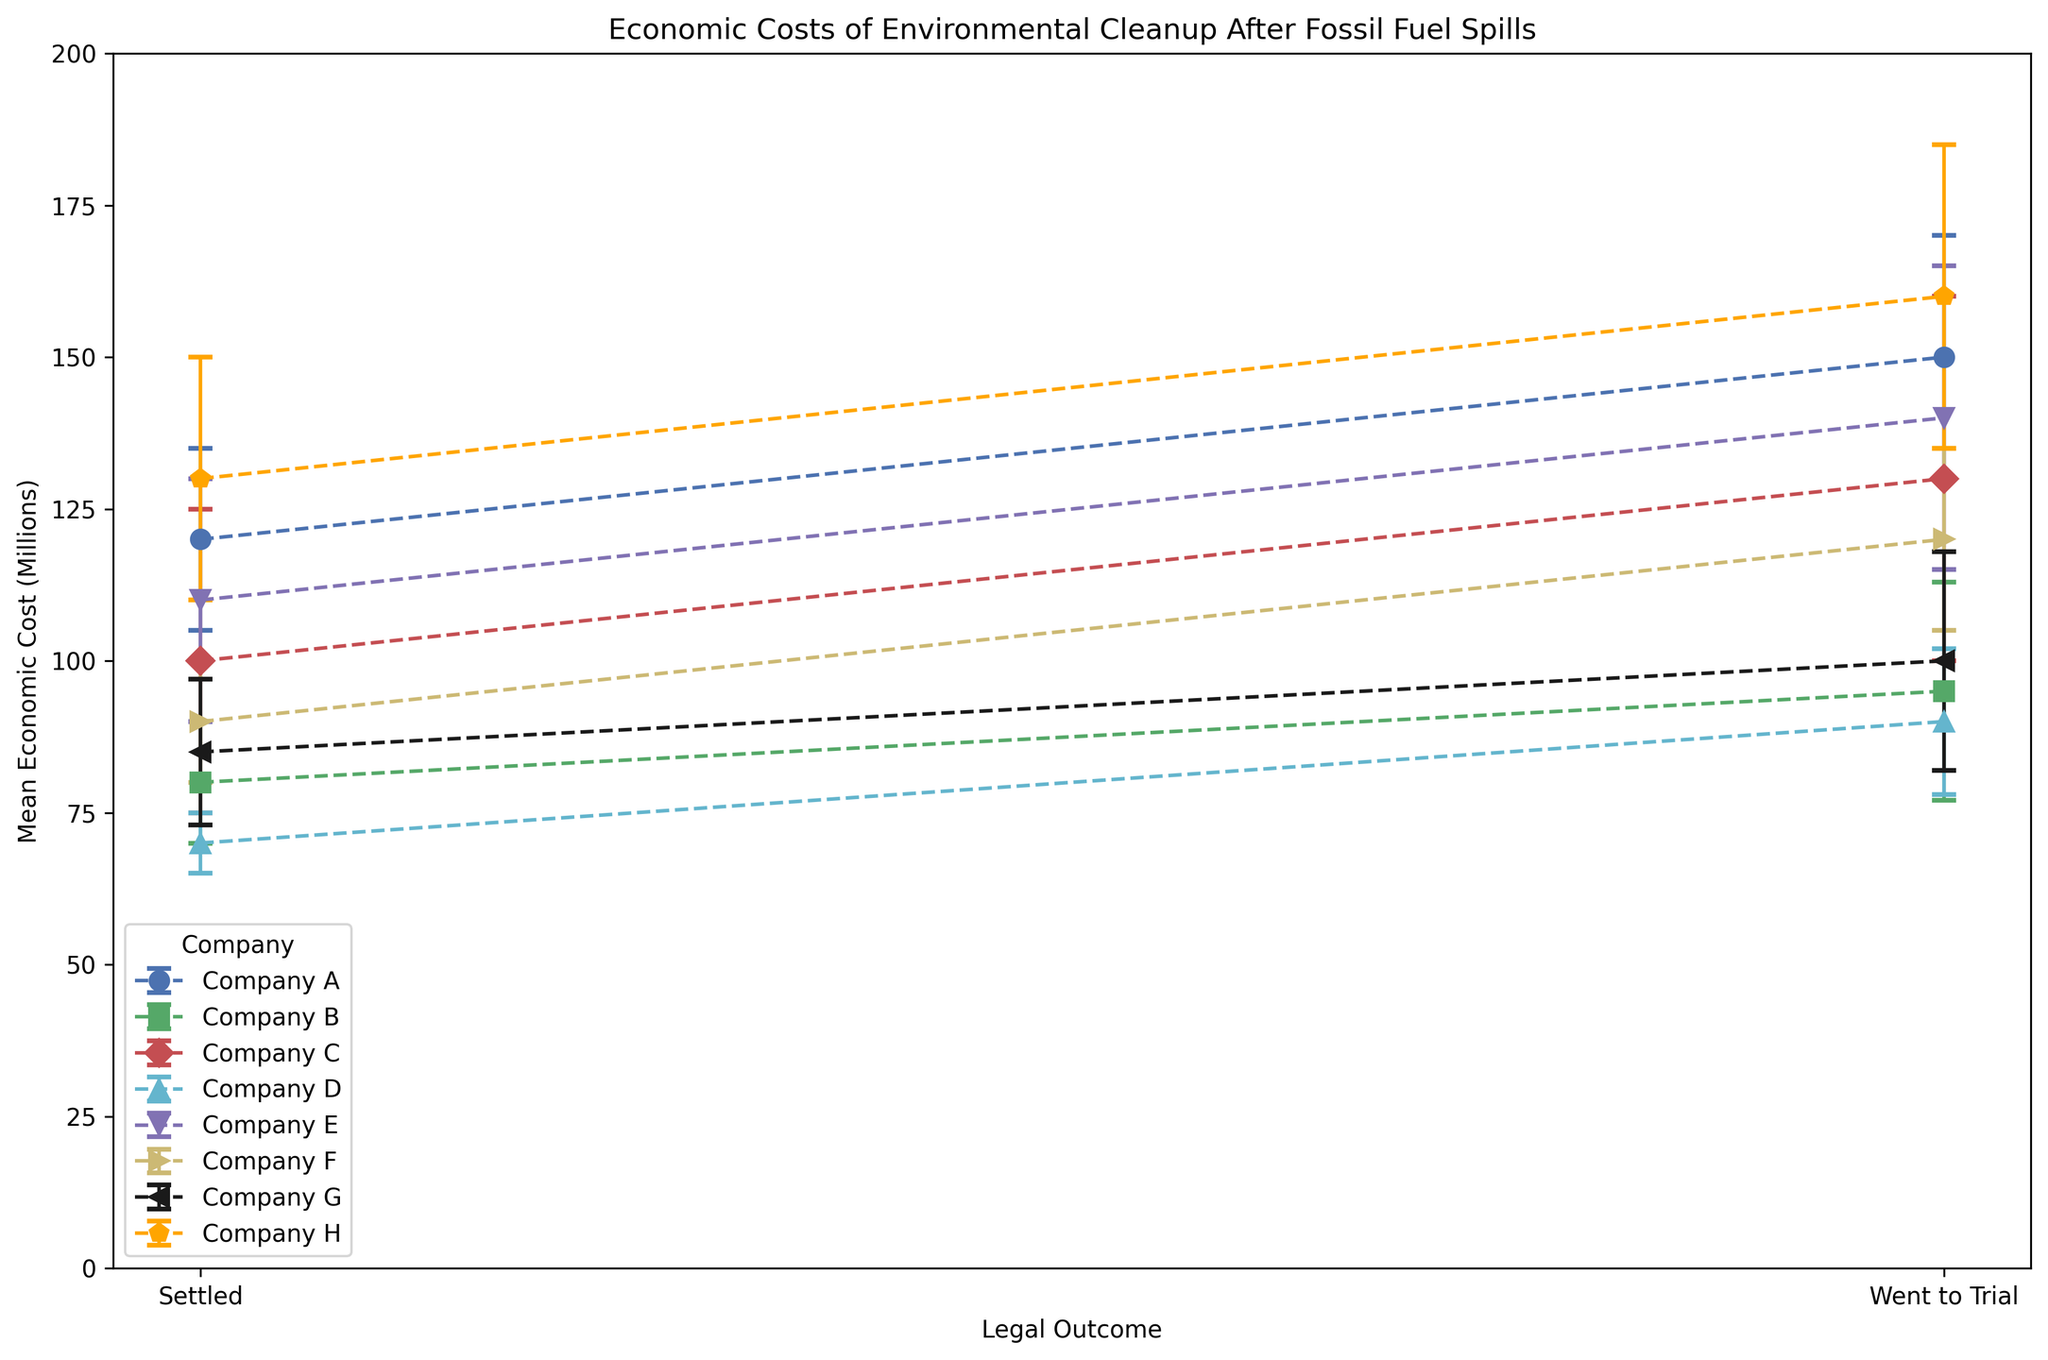What's the highest mean economic cost observed among all companies? To find the highest mean economic cost, look for the tallest error bar. The highest mean cost is for 'Company H' with 'Went to Trial' having a mean of 160 million.
Answer: 160 million Which company shows the smallest difference in mean economic cost between 'Settled' and 'Went to Trial' outcomes? To answer this, calculate the difference for each company. For 'Company D', the mean economic cost is 70 million for 'Settled' and 90 million for 'Went to Trial', a difference of 20 million, which is the smallest.
Answer: Company D How does 'Company C's' mean economic cost for 'Settled' compare to 'Company G's'? Look at the heights of the error bars for 'Settled' in both companies. 'Company C' has a mean cost of 100 million, and 'Company G' has a mean cost of 85 million. 'Company C' has a higher cost.
Answer: Company C is higher For 'Company E', what is the confidence interval (mean ± standard deviation) for 'Went to Trial'? For 'Company E' with 'Went to Trial', the mean is 140 million, and the standard deviation is 25 million. The confidence interval is (140 ± 25) million.
Answer: 115 to 165 million Compare the mean economic costs when settled between 'Company B' and 'Company H'. Which has a higher mean cost? By comparing the error bars for 'Settled', 'Company B' has a mean cost of 80 million, while 'Company H' has a mean cost of 130 million. 'Company H' has a higher mean cost.
Answer: Company H What is the range of mean economic costs for 'Settled' outcomes across all companies? The lowest mean economic cost for 'Settled' is 70 million ('Company D'), and the highest is 130 million ('Company H'). The range is (130 - 70) million.
Answer: 60 million Which legal outcome generally leads to higher economic costs based on the figure? Most companies show higher mean costs for 'Went to Trial' compared to 'Settled', indicated by taller bars for 'Went to Trial'.
Answer: Went to Trial Does 'Company A' exhibit a large variation in economic costs between 'Settled' and 'Went to Trial'? 'Company A' has a mean cost of 120 million for 'Settled' and 150 million for 'Went to Trial'. The difference is substantial (30 million), indicating a large variation.
Answer: Yes What's the average mean cost for 'Went to Trial' among all companies? Sum the mean costs for 'Went to Trial' for all companies: (150 + 95 + 130 + 90 + 140 + 120 + 100 + 160) / 8. The total is 985. The average is 985 / 8.
Answer: 123.125 million 